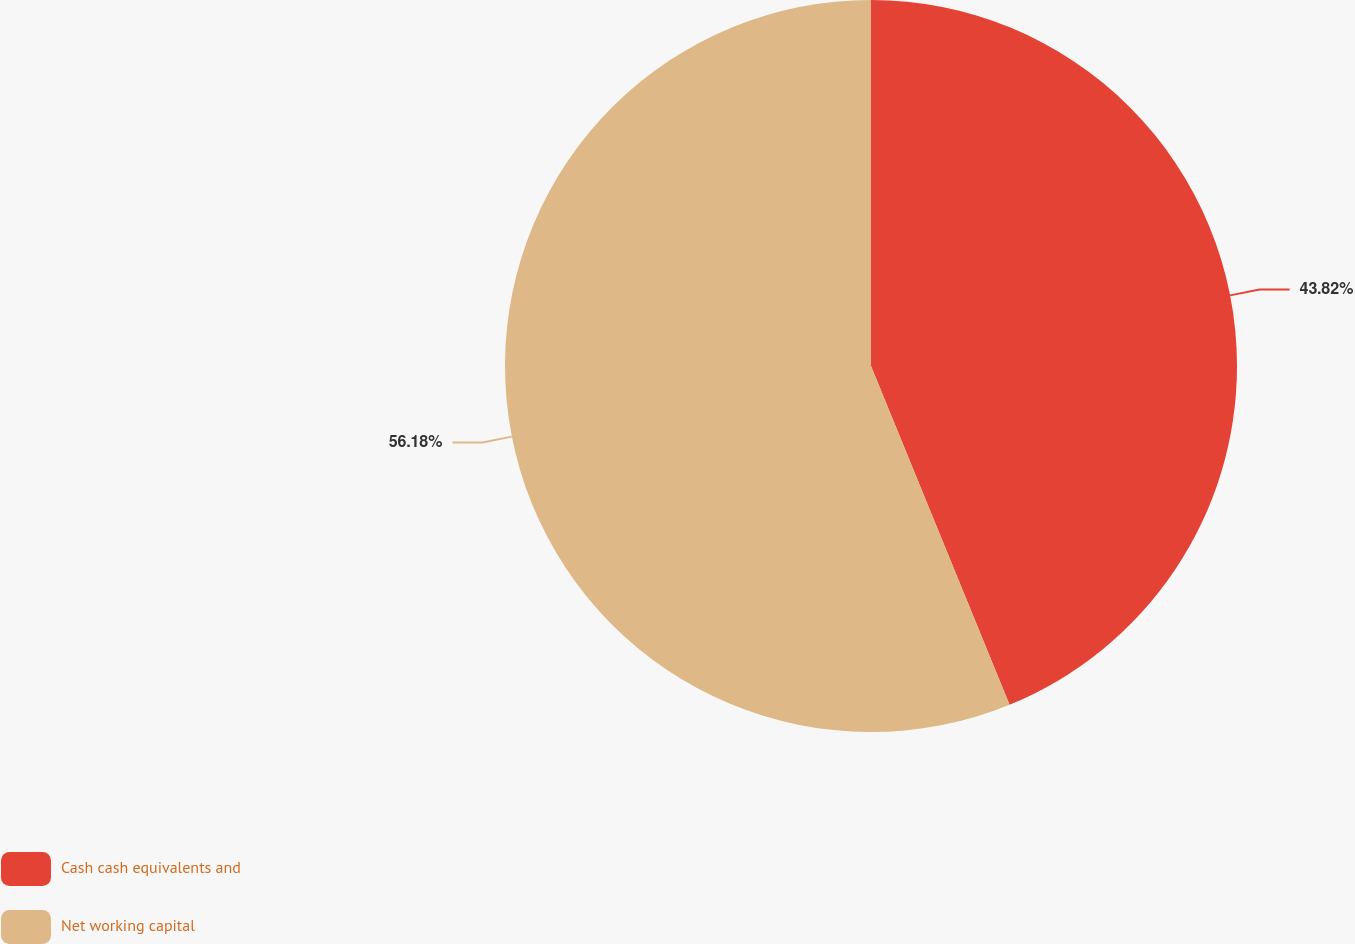Convert chart to OTSL. <chart><loc_0><loc_0><loc_500><loc_500><pie_chart><fcel>Cash cash equivalents and<fcel>Net working capital<nl><fcel>43.82%<fcel>56.18%<nl></chart> 